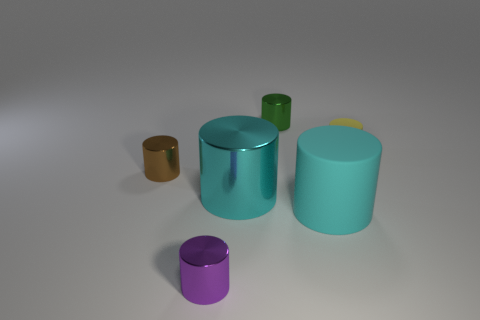Subtract 2 cylinders. How many cylinders are left? 4 Subtract all small purple cylinders. How many cylinders are left? 5 Subtract all yellow cylinders. How many cylinders are left? 5 Subtract all purple cylinders. Subtract all cyan blocks. How many cylinders are left? 5 Add 1 yellow things. How many objects exist? 7 Add 4 big purple blocks. How many big purple blocks exist? 4 Subtract 0 blue balls. How many objects are left? 6 Subtract all gray shiny cylinders. Subtract all purple metallic objects. How many objects are left? 5 Add 3 green objects. How many green objects are left? 4 